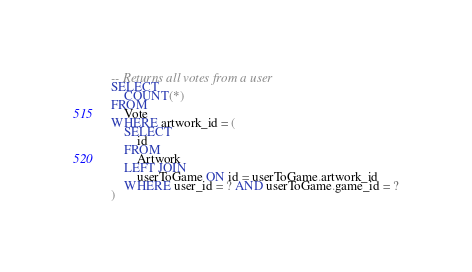<code> <loc_0><loc_0><loc_500><loc_500><_SQL_>-- Returns all votes from a user
SELECT
    COUNT(*)
FROM
    Vote
WHERE artwork_id = (
    SELECT
        id
    FROM
        Artwork
    LEFT JOIN
        userToGame ON id = userToGame.artwork_id
    WHERE user_id = ? AND userToGame.game_id = ?
)
</code> 